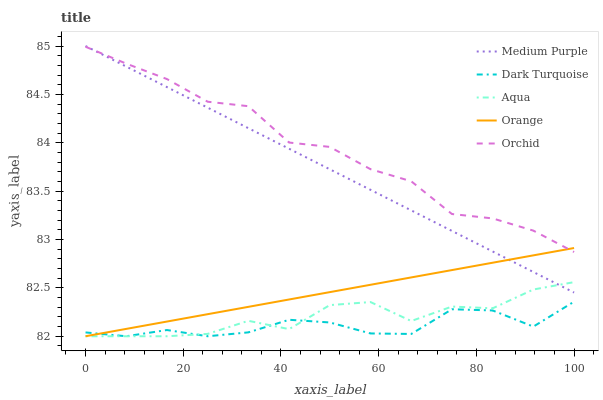Does Dark Turquoise have the minimum area under the curve?
Answer yes or no. Yes. Does Orchid have the maximum area under the curve?
Answer yes or no. Yes. Does Orange have the minimum area under the curve?
Answer yes or no. No. Does Orange have the maximum area under the curve?
Answer yes or no. No. Is Orange the smoothest?
Answer yes or no. Yes. Is Aqua the roughest?
Answer yes or no. Yes. Is Dark Turquoise the smoothest?
Answer yes or no. No. Is Dark Turquoise the roughest?
Answer yes or no. No. Does Dark Turquoise have the lowest value?
Answer yes or no. Yes. Does Orchid have the lowest value?
Answer yes or no. No. Does Medium Purple have the highest value?
Answer yes or no. Yes. Does Orange have the highest value?
Answer yes or no. No. Is Dark Turquoise less than Orchid?
Answer yes or no. Yes. Is Medium Purple greater than Dark Turquoise?
Answer yes or no. Yes. Does Medium Purple intersect Orange?
Answer yes or no. Yes. Is Medium Purple less than Orange?
Answer yes or no. No. Is Medium Purple greater than Orange?
Answer yes or no. No. Does Dark Turquoise intersect Orchid?
Answer yes or no. No. 